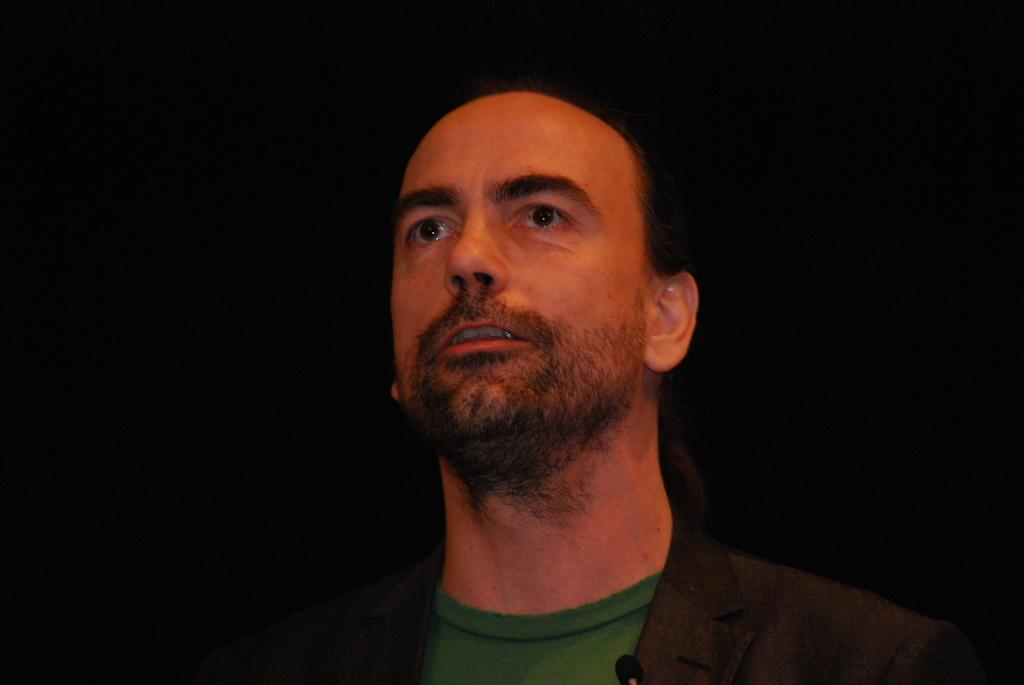What is the main subject of the image? There is a person in the image. What is the person doing in the image? The person is standing on the floor. Can you see any harbors or boats in the image? There is no mention of a harbor or boats in the provided facts, so we cannot determine their presence in the image. 